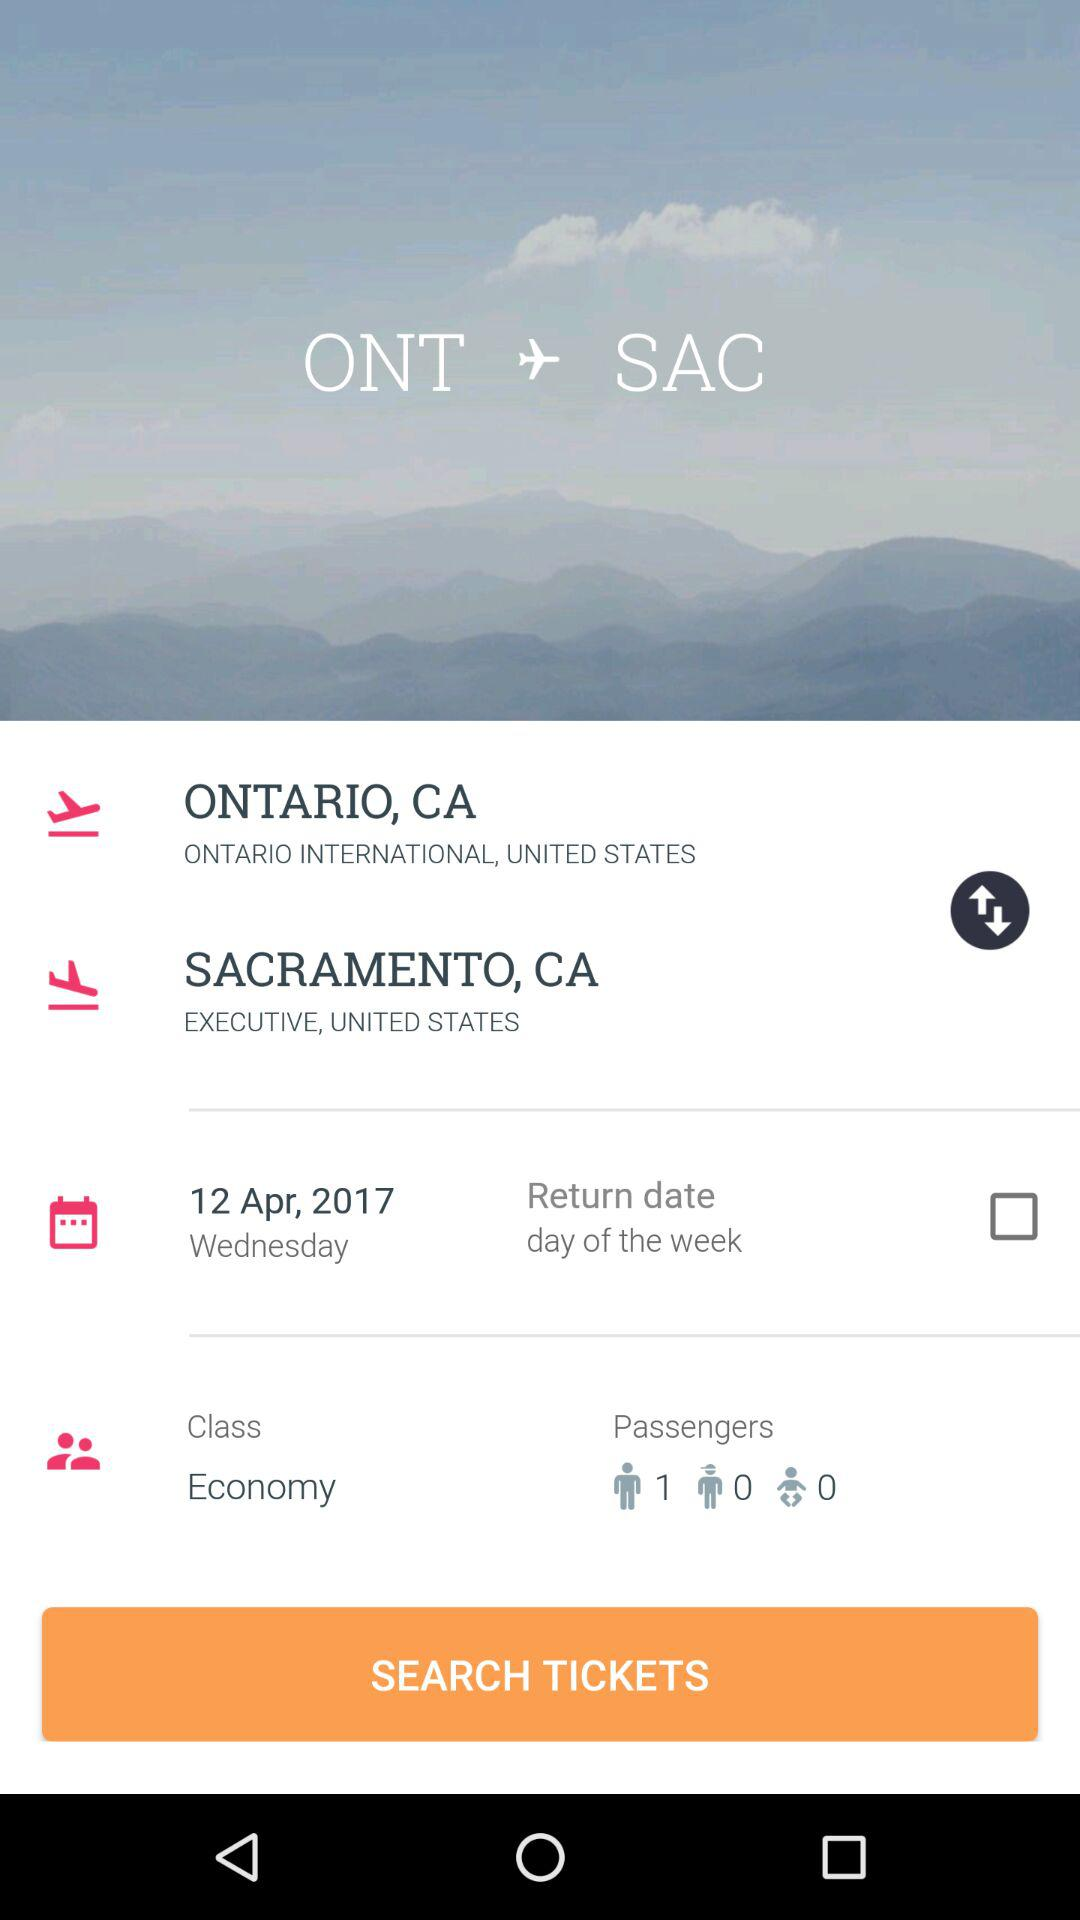How many people are flying?
Answer the question using a single word or phrase. 1 